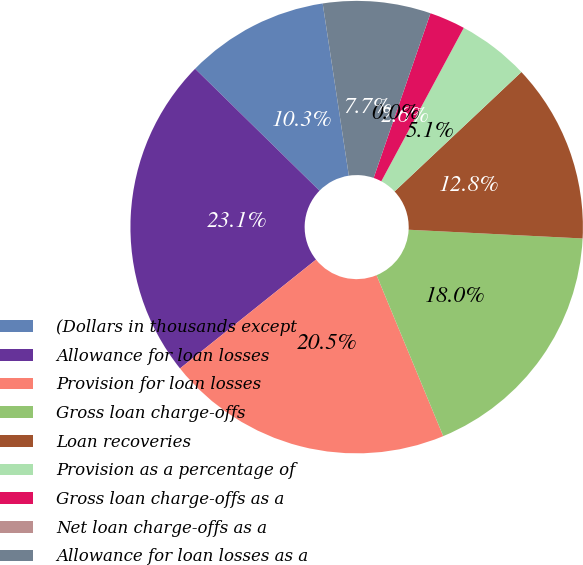<chart> <loc_0><loc_0><loc_500><loc_500><pie_chart><fcel>(Dollars in thousands except<fcel>Allowance for loan losses<fcel>Provision for loan losses<fcel>Gross loan charge-offs<fcel>Loan recoveries<fcel>Provision as a percentage of<fcel>Gross loan charge-offs as a<fcel>Net loan charge-offs as a<fcel>Allowance for loan losses as a<nl><fcel>10.26%<fcel>23.08%<fcel>20.51%<fcel>17.95%<fcel>12.82%<fcel>5.13%<fcel>2.56%<fcel>0.0%<fcel>7.69%<nl></chart> 